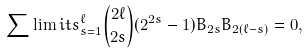<formula> <loc_0><loc_0><loc_500><loc_500>\sum \lim i t s _ { s = 1 } ^ { \ell } { 2 \ell \choose 2 s } ( 2 ^ { 2 s } - 1 ) B _ { 2 s } B _ { 2 ( \ell - s ) } = 0 ,</formula> 